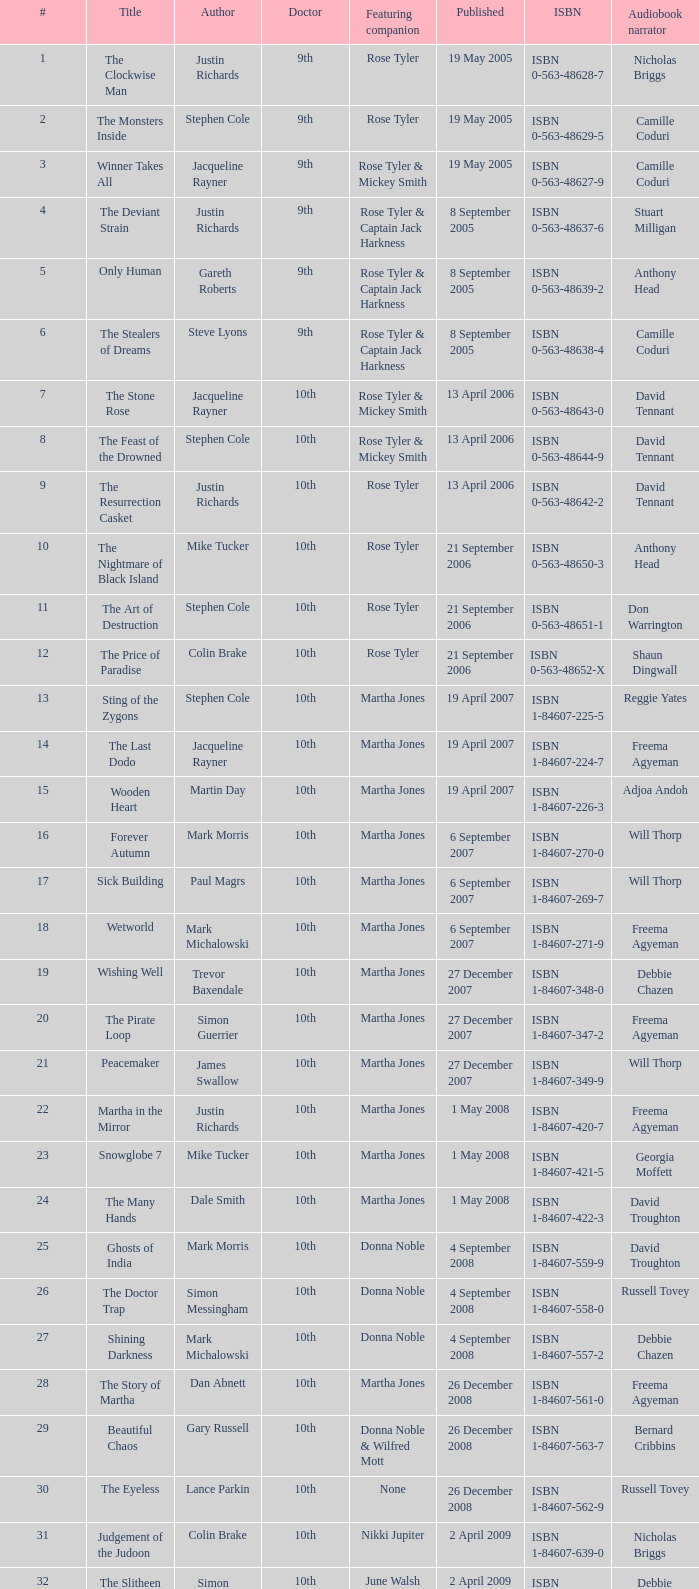Can you tell me the title of the 7th book? The Stone Rose. 